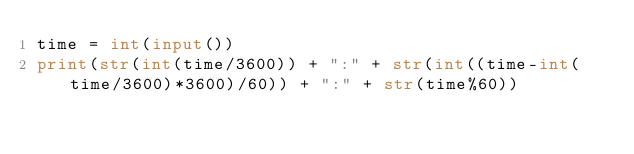<code> <loc_0><loc_0><loc_500><loc_500><_Python_>time = int(input())
print(str(int(time/3600)) + ":" + str(int((time-int(time/3600)*3600)/60)) + ":" + str(time%60))</code> 